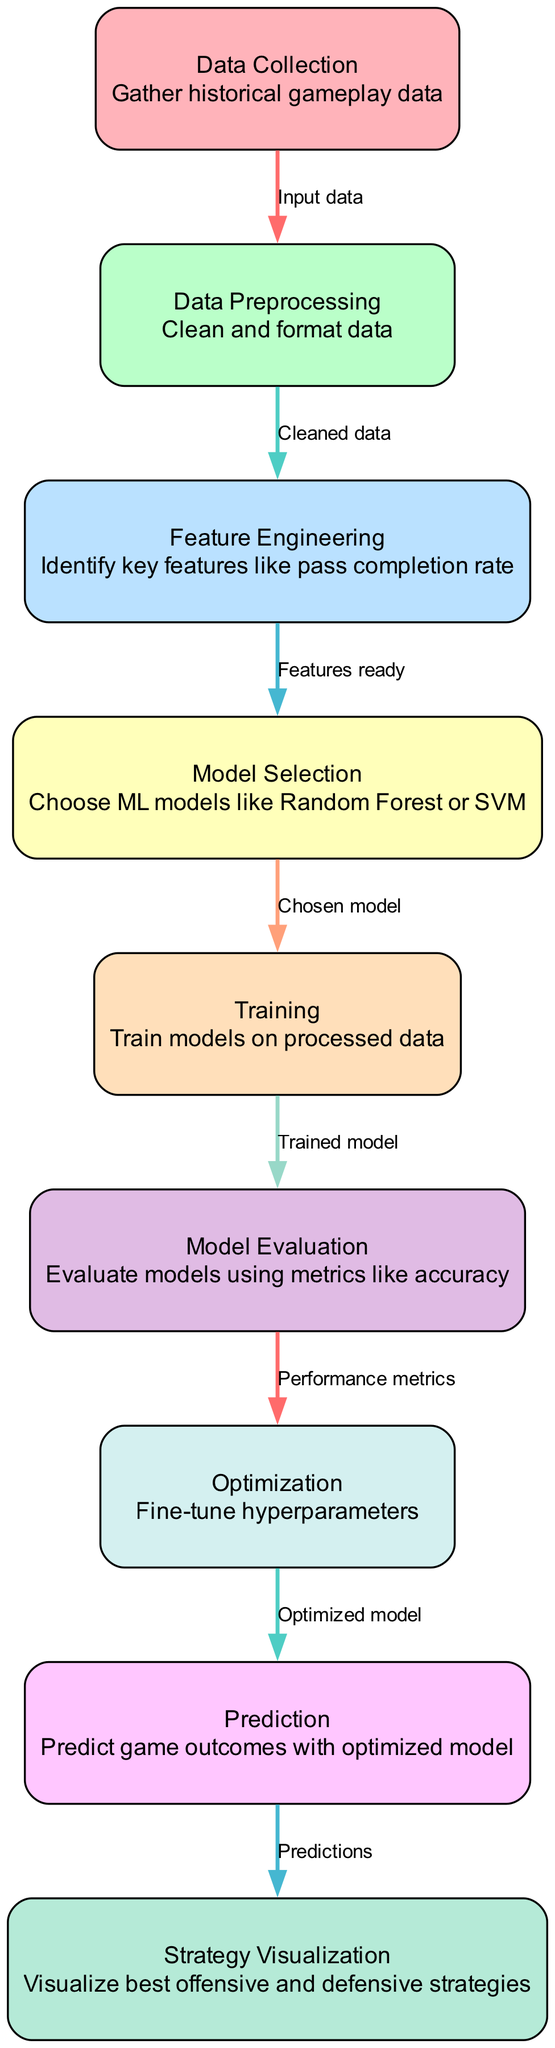What is the total number of nodes in the diagram? The diagram includes nine distinct nodes, each representing a different step in the machine learning process.
Answer: 9 What does node 5 represent? Node 5 is labeled "Training" and signifies the step where the models are trained on the processed data.
Answer: Training What is the relationship between nodes 3 and 4? The edge from node 3 (Feature Engineering) to node 4 (Model Selection) indicates that after identifying features, the next step is to select appropriate models.
Answer: Features ready Which node evaluates the model performance? Node 6 is responsible for evaluating models using various performance metrics such as accuracy.
Answer: Model Evaluation What type of data is fed into node 2? Node 2 receives "cleaned data" from the data preprocessing stage, which ensures the data is prepared for the next analysis steps.
Answer: Cleaned data Which node focuses on fine-tuning hyperparameters? Node 7, labeled "Optimization", specifically addresses the fine-tuning of hyperparameters to improve model performance.
Answer: Optimization Explain the flow from data collection to strategy visualization. The process begins with data collection (node 1) to gather gameplay data, then moves to data preprocessing (node 2) to clean that data. From there, feature engineering (node 3) is done to identify key aspects, followed by model selection (node 4). The model is then trained (node 5), evaluated (node 6), and optimized (node 7). Finally, predictions are made (node 8), which leads to visualizing the strategies (node 9).
Answer: Data Collection → Data Preprocessing → Feature Engineering → Model Selection → Training → Model Evaluation → Optimization → Prediction → Strategy Visualization What do the edges between nodes represent? The edges in the diagram represent the flow of information between different steps in the machine learning process, indicating dependencies and the order of operations.
Answer: Flow of information What is the primary objective of node 9? Node 9, labeled "Strategy Visualization", aims to visualize the best offensive and defensive strategies derived from the predictions made in the previous steps.
Answer: Visualize best strategies 